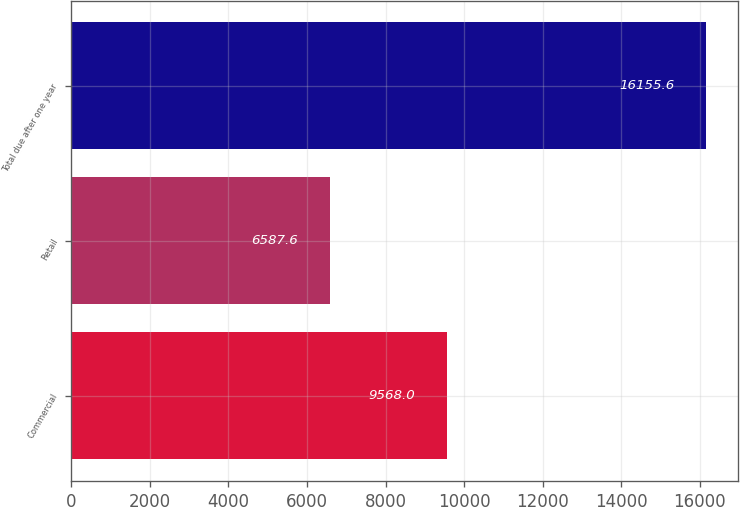Convert chart to OTSL. <chart><loc_0><loc_0><loc_500><loc_500><bar_chart><fcel>Commercial<fcel>Retail<fcel>Total due after one year<nl><fcel>9568<fcel>6587.6<fcel>16155.6<nl></chart> 